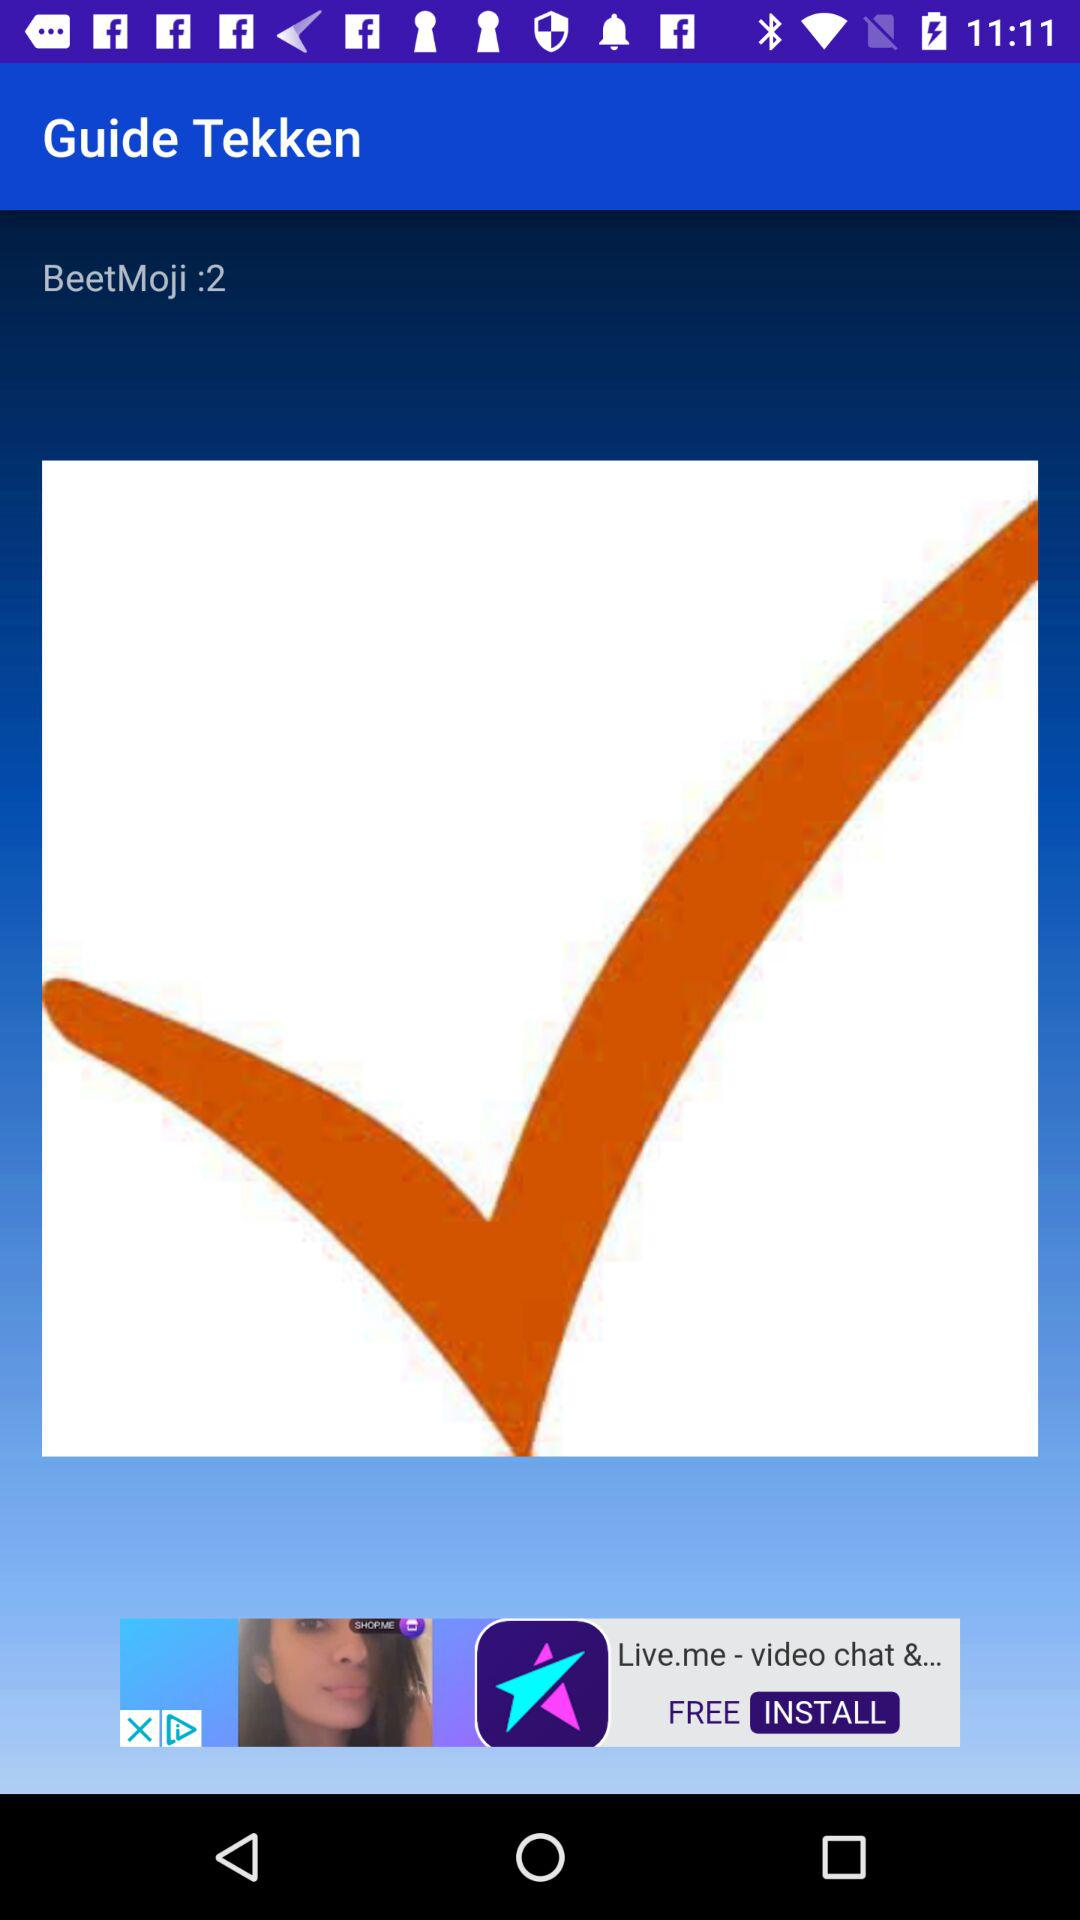Who is this application powered by?
When the provided information is insufficient, respond with <no answer>. <no answer> 